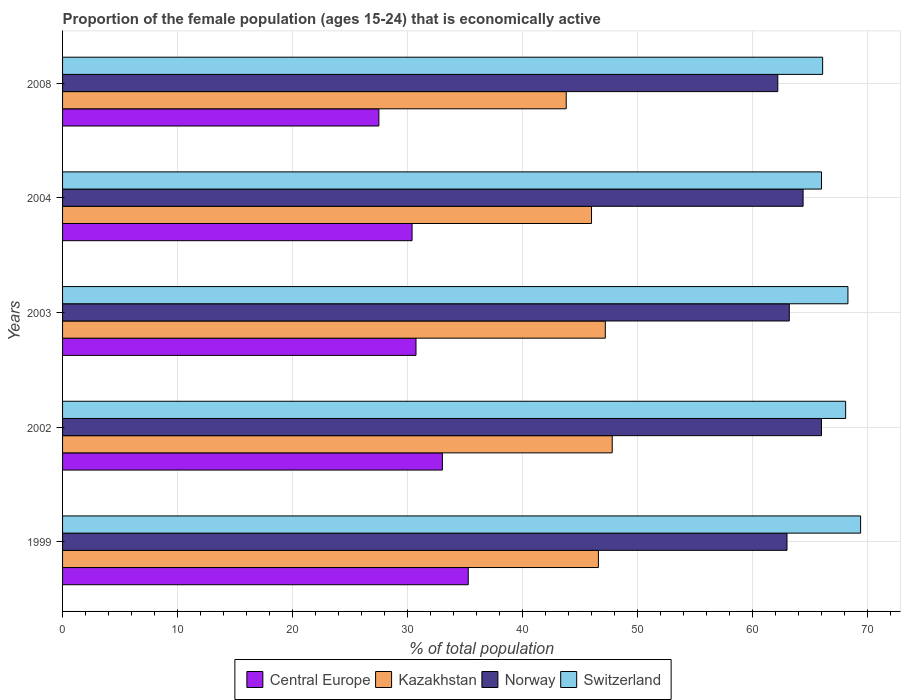How many different coloured bars are there?
Your answer should be very brief. 4. How many groups of bars are there?
Offer a very short reply. 5. Are the number of bars per tick equal to the number of legend labels?
Provide a short and direct response. Yes. Are the number of bars on each tick of the Y-axis equal?
Your answer should be very brief. Yes. How many bars are there on the 5th tick from the top?
Give a very brief answer. 4. How many bars are there on the 3rd tick from the bottom?
Offer a very short reply. 4. In how many cases, is the number of bars for a given year not equal to the number of legend labels?
Your answer should be compact. 0. What is the proportion of the female population that is economically active in Norway in 2002?
Your response must be concise. 66. Across all years, what is the maximum proportion of the female population that is economically active in Switzerland?
Keep it short and to the point. 69.4. Across all years, what is the minimum proportion of the female population that is economically active in Kazakhstan?
Provide a short and direct response. 43.8. In which year was the proportion of the female population that is economically active in Norway minimum?
Provide a succinct answer. 2008. What is the total proportion of the female population that is economically active in Kazakhstan in the graph?
Make the answer very short. 231.4. What is the difference between the proportion of the female population that is economically active in Central Europe in 2002 and that in 2008?
Your answer should be very brief. 5.53. What is the difference between the proportion of the female population that is economically active in Switzerland in 2008 and the proportion of the female population that is economically active in Central Europe in 2002?
Offer a terse response. 33.07. What is the average proportion of the female population that is economically active in Switzerland per year?
Your answer should be compact. 67.58. In the year 2004, what is the difference between the proportion of the female population that is economically active in Central Europe and proportion of the female population that is economically active in Switzerland?
Provide a short and direct response. -35.61. What is the ratio of the proportion of the female population that is economically active in Norway in 1999 to that in 2002?
Your answer should be very brief. 0.95. What is the difference between the highest and the second highest proportion of the female population that is economically active in Kazakhstan?
Your answer should be very brief. 0.6. What is the difference between the highest and the lowest proportion of the female population that is economically active in Switzerland?
Your answer should be compact. 3.4. In how many years, is the proportion of the female population that is economically active in Switzerland greater than the average proportion of the female population that is economically active in Switzerland taken over all years?
Offer a terse response. 3. What does the 3rd bar from the top in 1999 represents?
Ensure brevity in your answer.  Kazakhstan. What does the 2nd bar from the bottom in 1999 represents?
Your answer should be very brief. Kazakhstan. Are all the bars in the graph horizontal?
Your answer should be very brief. Yes. How many years are there in the graph?
Your answer should be very brief. 5. What is the difference between two consecutive major ticks on the X-axis?
Ensure brevity in your answer.  10. Does the graph contain any zero values?
Ensure brevity in your answer.  No. Does the graph contain grids?
Your answer should be compact. Yes. What is the title of the graph?
Make the answer very short. Proportion of the female population (ages 15-24) that is economically active. What is the label or title of the X-axis?
Make the answer very short. % of total population. What is the % of total population in Central Europe in 1999?
Your answer should be very brief. 35.28. What is the % of total population in Kazakhstan in 1999?
Your answer should be compact. 46.6. What is the % of total population of Switzerland in 1999?
Your response must be concise. 69.4. What is the % of total population in Central Europe in 2002?
Make the answer very short. 33.03. What is the % of total population in Kazakhstan in 2002?
Keep it short and to the point. 47.8. What is the % of total population of Switzerland in 2002?
Offer a very short reply. 68.1. What is the % of total population of Central Europe in 2003?
Give a very brief answer. 30.74. What is the % of total population in Kazakhstan in 2003?
Keep it short and to the point. 47.2. What is the % of total population of Norway in 2003?
Offer a very short reply. 63.2. What is the % of total population in Switzerland in 2003?
Offer a terse response. 68.3. What is the % of total population in Central Europe in 2004?
Give a very brief answer. 30.39. What is the % of total population in Kazakhstan in 2004?
Offer a very short reply. 46. What is the % of total population in Norway in 2004?
Make the answer very short. 64.4. What is the % of total population in Central Europe in 2008?
Make the answer very short. 27.51. What is the % of total population in Kazakhstan in 2008?
Your response must be concise. 43.8. What is the % of total population in Norway in 2008?
Keep it short and to the point. 62.2. What is the % of total population in Switzerland in 2008?
Keep it short and to the point. 66.1. Across all years, what is the maximum % of total population in Central Europe?
Offer a terse response. 35.28. Across all years, what is the maximum % of total population of Kazakhstan?
Provide a succinct answer. 47.8. Across all years, what is the maximum % of total population in Switzerland?
Your response must be concise. 69.4. Across all years, what is the minimum % of total population of Central Europe?
Your answer should be very brief. 27.51. Across all years, what is the minimum % of total population in Kazakhstan?
Keep it short and to the point. 43.8. Across all years, what is the minimum % of total population of Norway?
Keep it short and to the point. 62.2. Across all years, what is the minimum % of total population of Switzerland?
Your response must be concise. 66. What is the total % of total population in Central Europe in the graph?
Provide a succinct answer. 156.95. What is the total % of total population in Kazakhstan in the graph?
Your answer should be compact. 231.4. What is the total % of total population in Norway in the graph?
Your answer should be compact. 318.8. What is the total % of total population in Switzerland in the graph?
Offer a terse response. 337.9. What is the difference between the % of total population of Central Europe in 1999 and that in 2002?
Make the answer very short. 2.25. What is the difference between the % of total population of Kazakhstan in 1999 and that in 2002?
Your response must be concise. -1.2. What is the difference between the % of total population of Norway in 1999 and that in 2002?
Offer a very short reply. -3. What is the difference between the % of total population of Central Europe in 1999 and that in 2003?
Provide a succinct answer. 4.54. What is the difference between the % of total population in Kazakhstan in 1999 and that in 2003?
Your response must be concise. -0.6. What is the difference between the % of total population of Switzerland in 1999 and that in 2003?
Your answer should be very brief. 1.1. What is the difference between the % of total population in Central Europe in 1999 and that in 2004?
Your response must be concise. 4.89. What is the difference between the % of total population of Norway in 1999 and that in 2004?
Ensure brevity in your answer.  -1.4. What is the difference between the % of total population in Switzerland in 1999 and that in 2004?
Offer a terse response. 3.4. What is the difference between the % of total population in Central Europe in 1999 and that in 2008?
Provide a succinct answer. 7.77. What is the difference between the % of total population in Kazakhstan in 1999 and that in 2008?
Make the answer very short. 2.8. What is the difference between the % of total population of Norway in 1999 and that in 2008?
Keep it short and to the point. 0.8. What is the difference between the % of total population of Central Europe in 2002 and that in 2003?
Make the answer very short. 2.3. What is the difference between the % of total population in Kazakhstan in 2002 and that in 2003?
Offer a very short reply. 0.6. What is the difference between the % of total population in Switzerland in 2002 and that in 2003?
Keep it short and to the point. -0.2. What is the difference between the % of total population of Central Europe in 2002 and that in 2004?
Offer a terse response. 2.64. What is the difference between the % of total population of Kazakhstan in 2002 and that in 2004?
Offer a terse response. 1.8. What is the difference between the % of total population of Central Europe in 2002 and that in 2008?
Your answer should be very brief. 5.53. What is the difference between the % of total population of Norway in 2002 and that in 2008?
Provide a short and direct response. 3.8. What is the difference between the % of total population in Central Europe in 2003 and that in 2004?
Give a very brief answer. 0.34. What is the difference between the % of total population in Switzerland in 2003 and that in 2004?
Give a very brief answer. 2.3. What is the difference between the % of total population in Central Europe in 2003 and that in 2008?
Provide a succinct answer. 3.23. What is the difference between the % of total population in Kazakhstan in 2003 and that in 2008?
Give a very brief answer. 3.4. What is the difference between the % of total population in Central Europe in 2004 and that in 2008?
Ensure brevity in your answer.  2.89. What is the difference between the % of total population in Kazakhstan in 2004 and that in 2008?
Provide a short and direct response. 2.2. What is the difference between the % of total population in Central Europe in 1999 and the % of total population in Kazakhstan in 2002?
Give a very brief answer. -12.52. What is the difference between the % of total population of Central Europe in 1999 and the % of total population of Norway in 2002?
Offer a very short reply. -30.72. What is the difference between the % of total population in Central Europe in 1999 and the % of total population in Switzerland in 2002?
Your response must be concise. -32.82. What is the difference between the % of total population in Kazakhstan in 1999 and the % of total population in Norway in 2002?
Your answer should be very brief. -19.4. What is the difference between the % of total population of Kazakhstan in 1999 and the % of total population of Switzerland in 2002?
Your response must be concise. -21.5. What is the difference between the % of total population in Central Europe in 1999 and the % of total population in Kazakhstan in 2003?
Your answer should be compact. -11.92. What is the difference between the % of total population of Central Europe in 1999 and the % of total population of Norway in 2003?
Offer a very short reply. -27.92. What is the difference between the % of total population in Central Europe in 1999 and the % of total population in Switzerland in 2003?
Provide a short and direct response. -33.02. What is the difference between the % of total population in Kazakhstan in 1999 and the % of total population in Norway in 2003?
Offer a terse response. -16.6. What is the difference between the % of total population in Kazakhstan in 1999 and the % of total population in Switzerland in 2003?
Provide a short and direct response. -21.7. What is the difference between the % of total population in Norway in 1999 and the % of total population in Switzerland in 2003?
Provide a succinct answer. -5.3. What is the difference between the % of total population in Central Europe in 1999 and the % of total population in Kazakhstan in 2004?
Provide a short and direct response. -10.72. What is the difference between the % of total population of Central Europe in 1999 and the % of total population of Norway in 2004?
Give a very brief answer. -29.12. What is the difference between the % of total population of Central Europe in 1999 and the % of total population of Switzerland in 2004?
Keep it short and to the point. -30.72. What is the difference between the % of total population in Kazakhstan in 1999 and the % of total population in Norway in 2004?
Provide a succinct answer. -17.8. What is the difference between the % of total population of Kazakhstan in 1999 and the % of total population of Switzerland in 2004?
Your answer should be very brief. -19.4. What is the difference between the % of total population in Central Europe in 1999 and the % of total population in Kazakhstan in 2008?
Offer a terse response. -8.52. What is the difference between the % of total population in Central Europe in 1999 and the % of total population in Norway in 2008?
Provide a succinct answer. -26.92. What is the difference between the % of total population of Central Europe in 1999 and the % of total population of Switzerland in 2008?
Offer a terse response. -30.82. What is the difference between the % of total population of Kazakhstan in 1999 and the % of total population of Norway in 2008?
Give a very brief answer. -15.6. What is the difference between the % of total population in Kazakhstan in 1999 and the % of total population in Switzerland in 2008?
Give a very brief answer. -19.5. What is the difference between the % of total population of Norway in 1999 and the % of total population of Switzerland in 2008?
Keep it short and to the point. -3.1. What is the difference between the % of total population of Central Europe in 2002 and the % of total population of Kazakhstan in 2003?
Provide a succinct answer. -14.17. What is the difference between the % of total population of Central Europe in 2002 and the % of total population of Norway in 2003?
Give a very brief answer. -30.17. What is the difference between the % of total population in Central Europe in 2002 and the % of total population in Switzerland in 2003?
Make the answer very short. -35.27. What is the difference between the % of total population of Kazakhstan in 2002 and the % of total population of Norway in 2003?
Keep it short and to the point. -15.4. What is the difference between the % of total population of Kazakhstan in 2002 and the % of total population of Switzerland in 2003?
Make the answer very short. -20.5. What is the difference between the % of total population in Norway in 2002 and the % of total population in Switzerland in 2003?
Your answer should be compact. -2.3. What is the difference between the % of total population in Central Europe in 2002 and the % of total population in Kazakhstan in 2004?
Your answer should be compact. -12.97. What is the difference between the % of total population of Central Europe in 2002 and the % of total population of Norway in 2004?
Give a very brief answer. -31.37. What is the difference between the % of total population of Central Europe in 2002 and the % of total population of Switzerland in 2004?
Ensure brevity in your answer.  -32.97. What is the difference between the % of total population of Kazakhstan in 2002 and the % of total population of Norway in 2004?
Ensure brevity in your answer.  -16.6. What is the difference between the % of total population of Kazakhstan in 2002 and the % of total population of Switzerland in 2004?
Give a very brief answer. -18.2. What is the difference between the % of total population of Central Europe in 2002 and the % of total population of Kazakhstan in 2008?
Provide a succinct answer. -10.77. What is the difference between the % of total population in Central Europe in 2002 and the % of total population in Norway in 2008?
Your response must be concise. -29.17. What is the difference between the % of total population of Central Europe in 2002 and the % of total population of Switzerland in 2008?
Provide a succinct answer. -33.07. What is the difference between the % of total population of Kazakhstan in 2002 and the % of total population of Norway in 2008?
Provide a short and direct response. -14.4. What is the difference between the % of total population of Kazakhstan in 2002 and the % of total population of Switzerland in 2008?
Give a very brief answer. -18.3. What is the difference between the % of total population in Central Europe in 2003 and the % of total population in Kazakhstan in 2004?
Provide a short and direct response. -15.26. What is the difference between the % of total population in Central Europe in 2003 and the % of total population in Norway in 2004?
Give a very brief answer. -33.66. What is the difference between the % of total population of Central Europe in 2003 and the % of total population of Switzerland in 2004?
Keep it short and to the point. -35.26. What is the difference between the % of total population of Kazakhstan in 2003 and the % of total population of Norway in 2004?
Provide a succinct answer. -17.2. What is the difference between the % of total population in Kazakhstan in 2003 and the % of total population in Switzerland in 2004?
Ensure brevity in your answer.  -18.8. What is the difference between the % of total population of Norway in 2003 and the % of total population of Switzerland in 2004?
Ensure brevity in your answer.  -2.8. What is the difference between the % of total population of Central Europe in 2003 and the % of total population of Kazakhstan in 2008?
Give a very brief answer. -13.06. What is the difference between the % of total population in Central Europe in 2003 and the % of total population in Norway in 2008?
Your response must be concise. -31.46. What is the difference between the % of total population of Central Europe in 2003 and the % of total population of Switzerland in 2008?
Ensure brevity in your answer.  -35.36. What is the difference between the % of total population in Kazakhstan in 2003 and the % of total population in Norway in 2008?
Keep it short and to the point. -15. What is the difference between the % of total population in Kazakhstan in 2003 and the % of total population in Switzerland in 2008?
Provide a succinct answer. -18.9. What is the difference between the % of total population in Central Europe in 2004 and the % of total population in Kazakhstan in 2008?
Offer a very short reply. -13.41. What is the difference between the % of total population of Central Europe in 2004 and the % of total population of Norway in 2008?
Ensure brevity in your answer.  -31.81. What is the difference between the % of total population of Central Europe in 2004 and the % of total population of Switzerland in 2008?
Keep it short and to the point. -35.71. What is the difference between the % of total population in Kazakhstan in 2004 and the % of total population in Norway in 2008?
Offer a very short reply. -16.2. What is the difference between the % of total population in Kazakhstan in 2004 and the % of total population in Switzerland in 2008?
Your answer should be very brief. -20.1. What is the difference between the % of total population of Norway in 2004 and the % of total population of Switzerland in 2008?
Offer a terse response. -1.7. What is the average % of total population of Central Europe per year?
Provide a short and direct response. 31.39. What is the average % of total population of Kazakhstan per year?
Keep it short and to the point. 46.28. What is the average % of total population in Norway per year?
Your answer should be very brief. 63.76. What is the average % of total population in Switzerland per year?
Offer a very short reply. 67.58. In the year 1999, what is the difference between the % of total population in Central Europe and % of total population in Kazakhstan?
Offer a terse response. -11.32. In the year 1999, what is the difference between the % of total population in Central Europe and % of total population in Norway?
Provide a succinct answer. -27.72. In the year 1999, what is the difference between the % of total population of Central Europe and % of total population of Switzerland?
Offer a terse response. -34.12. In the year 1999, what is the difference between the % of total population in Kazakhstan and % of total population in Norway?
Provide a short and direct response. -16.4. In the year 1999, what is the difference between the % of total population in Kazakhstan and % of total population in Switzerland?
Provide a succinct answer. -22.8. In the year 2002, what is the difference between the % of total population of Central Europe and % of total population of Kazakhstan?
Provide a succinct answer. -14.77. In the year 2002, what is the difference between the % of total population of Central Europe and % of total population of Norway?
Your response must be concise. -32.97. In the year 2002, what is the difference between the % of total population of Central Europe and % of total population of Switzerland?
Provide a succinct answer. -35.07. In the year 2002, what is the difference between the % of total population of Kazakhstan and % of total population of Norway?
Provide a short and direct response. -18.2. In the year 2002, what is the difference between the % of total population of Kazakhstan and % of total population of Switzerland?
Your answer should be compact. -20.3. In the year 2003, what is the difference between the % of total population of Central Europe and % of total population of Kazakhstan?
Your response must be concise. -16.46. In the year 2003, what is the difference between the % of total population of Central Europe and % of total population of Norway?
Give a very brief answer. -32.46. In the year 2003, what is the difference between the % of total population of Central Europe and % of total population of Switzerland?
Keep it short and to the point. -37.56. In the year 2003, what is the difference between the % of total population of Kazakhstan and % of total population of Switzerland?
Your response must be concise. -21.1. In the year 2004, what is the difference between the % of total population of Central Europe and % of total population of Kazakhstan?
Provide a short and direct response. -15.61. In the year 2004, what is the difference between the % of total population in Central Europe and % of total population in Norway?
Keep it short and to the point. -34.01. In the year 2004, what is the difference between the % of total population of Central Europe and % of total population of Switzerland?
Ensure brevity in your answer.  -35.61. In the year 2004, what is the difference between the % of total population in Kazakhstan and % of total population in Norway?
Your answer should be very brief. -18.4. In the year 2004, what is the difference between the % of total population of Kazakhstan and % of total population of Switzerland?
Give a very brief answer. -20. In the year 2004, what is the difference between the % of total population of Norway and % of total population of Switzerland?
Make the answer very short. -1.6. In the year 2008, what is the difference between the % of total population in Central Europe and % of total population in Kazakhstan?
Ensure brevity in your answer.  -16.29. In the year 2008, what is the difference between the % of total population in Central Europe and % of total population in Norway?
Your response must be concise. -34.69. In the year 2008, what is the difference between the % of total population in Central Europe and % of total population in Switzerland?
Your response must be concise. -38.59. In the year 2008, what is the difference between the % of total population of Kazakhstan and % of total population of Norway?
Ensure brevity in your answer.  -18.4. In the year 2008, what is the difference between the % of total population of Kazakhstan and % of total population of Switzerland?
Keep it short and to the point. -22.3. In the year 2008, what is the difference between the % of total population of Norway and % of total population of Switzerland?
Your response must be concise. -3.9. What is the ratio of the % of total population of Central Europe in 1999 to that in 2002?
Offer a very short reply. 1.07. What is the ratio of the % of total population of Kazakhstan in 1999 to that in 2002?
Provide a succinct answer. 0.97. What is the ratio of the % of total population in Norway in 1999 to that in 2002?
Your answer should be compact. 0.95. What is the ratio of the % of total population in Switzerland in 1999 to that in 2002?
Ensure brevity in your answer.  1.02. What is the ratio of the % of total population in Central Europe in 1999 to that in 2003?
Provide a succinct answer. 1.15. What is the ratio of the % of total population in Kazakhstan in 1999 to that in 2003?
Provide a short and direct response. 0.99. What is the ratio of the % of total population of Norway in 1999 to that in 2003?
Your answer should be very brief. 1. What is the ratio of the % of total population in Switzerland in 1999 to that in 2003?
Give a very brief answer. 1.02. What is the ratio of the % of total population of Central Europe in 1999 to that in 2004?
Provide a short and direct response. 1.16. What is the ratio of the % of total population of Norway in 1999 to that in 2004?
Your answer should be very brief. 0.98. What is the ratio of the % of total population in Switzerland in 1999 to that in 2004?
Your answer should be very brief. 1.05. What is the ratio of the % of total population of Central Europe in 1999 to that in 2008?
Provide a succinct answer. 1.28. What is the ratio of the % of total population in Kazakhstan in 1999 to that in 2008?
Provide a succinct answer. 1.06. What is the ratio of the % of total population of Norway in 1999 to that in 2008?
Offer a terse response. 1.01. What is the ratio of the % of total population in Switzerland in 1999 to that in 2008?
Your answer should be compact. 1.05. What is the ratio of the % of total population in Central Europe in 2002 to that in 2003?
Keep it short and to the point. 1.07. What is the ratio of the % of total population of Kazakhstan in 2002 to that in 2003?
Your answer should be compact. 1.01. What is the ratio of the % of total population in Norway in 2002 to that in 2003?
Provide a succinct answer. 1.04. What is the ratio of the % of total population of Switzerland in 2002 to that in 2003?
Keep it short and to the point. 1. What is the ratio of the % of total population of Central Europe in 2002 to that in 2004?
Provide a short and direct response. 1.09. What is the ratio of the % of total population of Kazakhstan in 2002 to that in 2004?
Give a very brief answer. 1.04. What is the ratio of the % of total population in Norway in 2002 to that in 2004?
Your answer should be compact. 1.02. What is the ratio of the % of total population of Switzerland in 2002 to that in 2004?
Your response must be concise. 1.03. What is the ratio of the % of total population of Central Europe in 2002 to that in 2008?
Provide a short and direct response. 1.2. What is the ratio of the % of total population in Kazakhstan in 2002 to that in 2008?
Keep it short and to the point. 1.09. What is the ratio of the % of total population in Norway in 2002 to that in 2008?
Offer a terse response. 1.06. What is the ratio of the % of total population of Switzerland in 2002 to that in 2008?
Offer a very short reply. 1.03. What is the ratio of the % of total population of Central Europe in 2003 to that in 2004?
Your answer should be very brief. 1.01. What is the ratio of the % of total population of Kazakhstan in 2003 to that in 2004?
Offer a terse response. 1.03. What is the ratio of the % of total population of Norway in 2003 to that in 2004?
Offer a very short reply. 0.98. What is the ratio of the % of total population in Switzerland in 2003 to that in 2004?
Ensure brevity in your answer.  1.03. What is the ratio of the % of total population of Central Europe in 2003 to that in 2008?
Your answer should be compact. 1.12. What is the ratio of the % of total population in Kazakhstan in 2003 to that in 2008?
Ensure brevity in your answer.  1.08. What is the ratio of the % of total population in Norway in 2003 to that in 2008?
Your answer should be very brief. 1.02. What is the ratio of the % of total population in Central Europe in 2004 to that in 2008?
Your answer should be compact. 1.1. What is the ratio of the % of total population in Kazakhstan in 2004 to that in 2008?
Provide a short and direct response. 1.05. What is the ratio of the % of total population of Norway in 2004 to that in 2008?
Ensure brevity in your answer.  1.04. What is the ratio of the % of total population in Switzerland in 2004 to that in 2008?
Ensure brevity in your answer.  1. What is the difference between the highest and the second highest % of total population of Central Europe?
Your answer should be very brief. 2.25. What is the difference between the highest and the second highest % of total population of Kazakhstan?
Offer a very short reply. 0.6. What is the difference between the highest and the second highest % of total population of Norway?
Provide a succinct answer. 1.6. What is the difference between the highest and the lowest % of total population in Central Europe?
Offer a very short reply. 7.77. What is the difference between the highest and the lowest % of total population in Norway?
Provide a succinct answer. 3.8. 